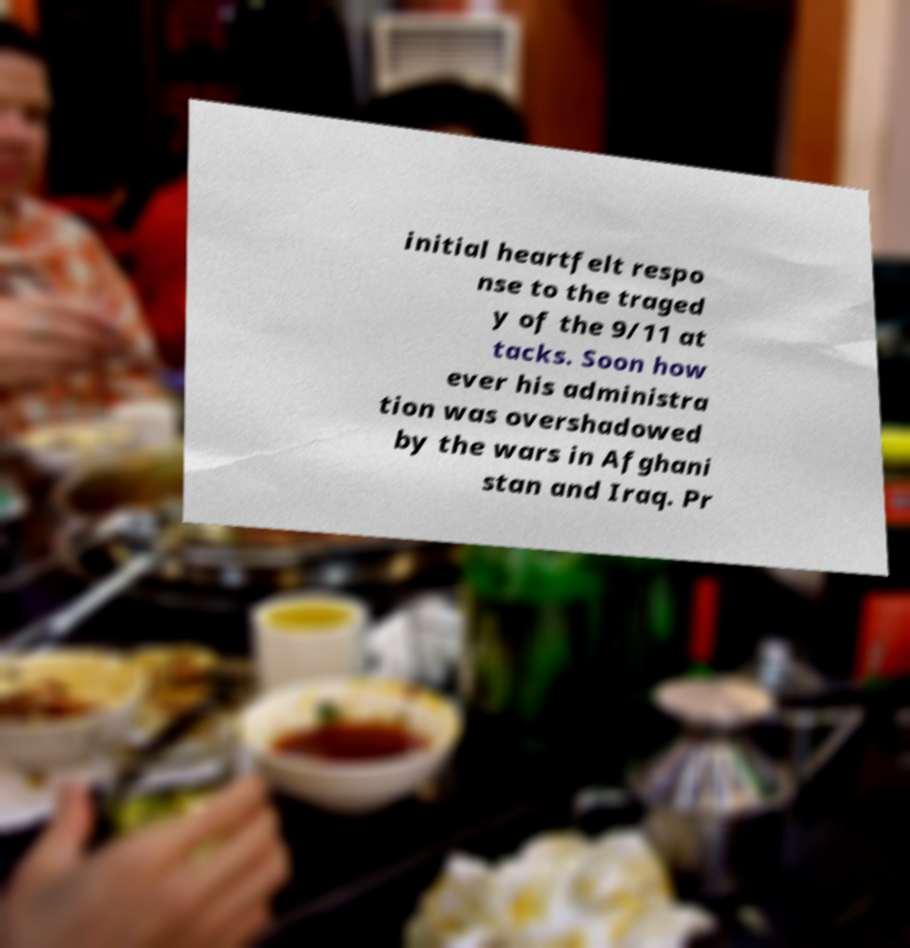For documentation purposes, I need the text within this image transcribed. Could you provide that? initial heartfelt respo nse to the traged y of the 9/11 at tacks. Soon how ever his administra tion was overshadowed by the wars in Afghani stan and Iraq. Pr 